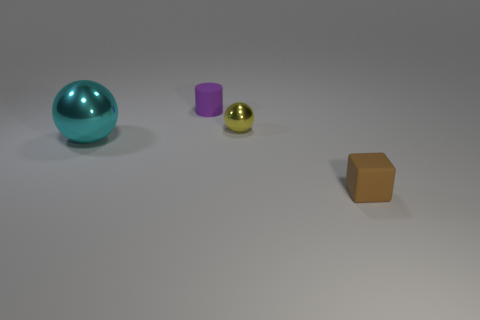Add 3 balls. How many objects exist? 7 Subtract all cylinders. How many objects are left? 3 Subtract 0 cyan cubes. How many objects are left? 4 Subtract all yellow metallic cylinders. Subtract all small things. How many objects are left? 1 Add 3 metal spheres. How many metal spheres are left? 5 Add 2 small yellow balls. How many small yellow balls exist? 3 